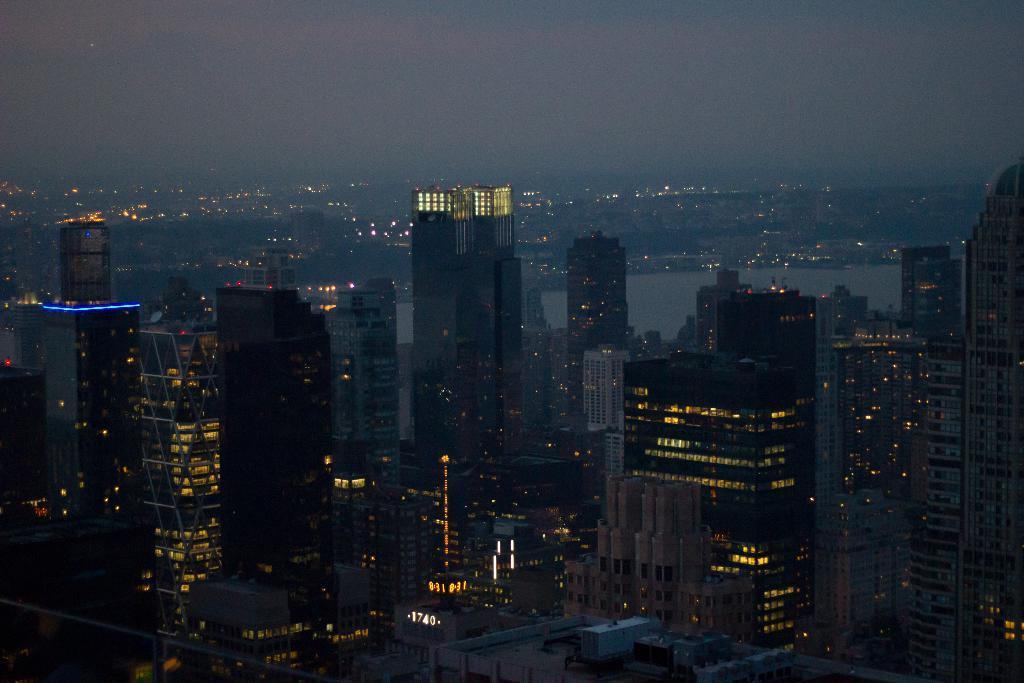Please provide a concise description of this image. In the foreground, I can see buildings, lights, towers, water and trees. At the top, I can see the sky. This picture might be taken during night. 